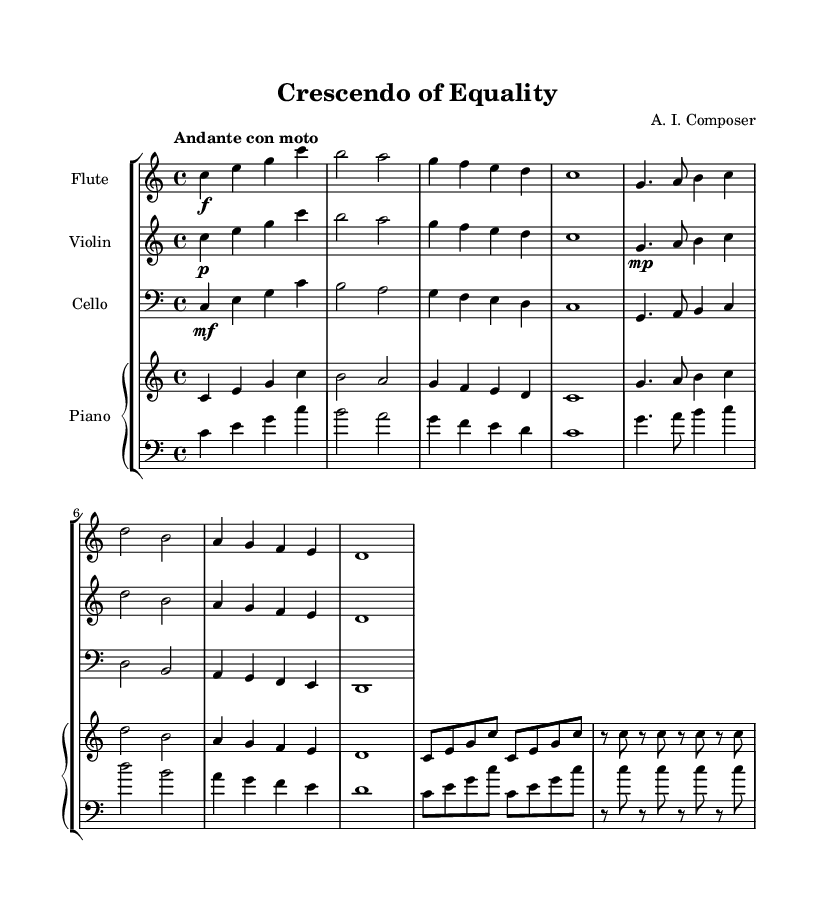What is the key signature of this music? The key signature is C major, which has no sharps or flats.
Answer: C major What is the time signature of this piece? The time signature is indicated as 4/4, which means there are four beats in a measure.
Answer: 4/4 What is the tempo marking of the composition? The tempo marking is "Andante con moto", which suggests a moderately slow pace with some movement.
Answer: Andante con moto How many measures are in the piece? By counting the measures in the provided staves, there are 10 measures in the entire piece.
Answer: 10 Which instrument plays the highest notes? The flute consistently plays the highest notes throughout the piece compared to the other instruments.
Answer: Flute What dynamic marking is indicated for the violin? The violin part is marked with a piano dynamic, which means it should be played softly.
Answer: Piano What is the ending dynamic for the cello part? The ending dynamic for the cello part is marked as 1, indicating a sustained sound, likely a forte or loud playing for impact.
Answer: 1 